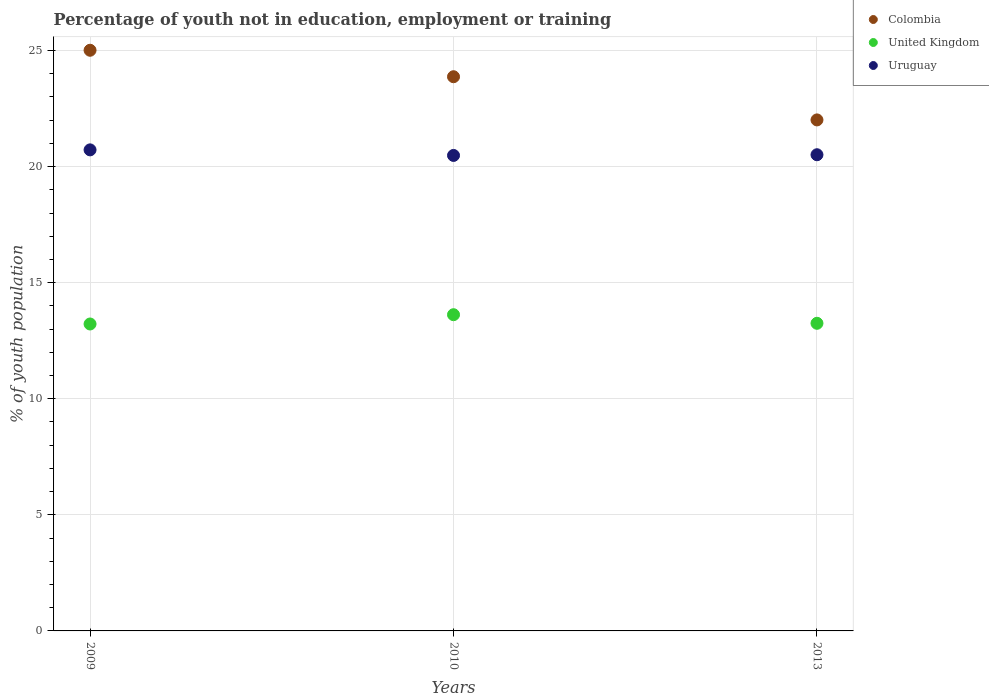What is the percentage of unemployed youth population in in Colombia in 2009?
Make the answer very short. 25.01. Across all years, what is the maximum percentage of unemployed youth population in in Colombia?
Make the answer very short. 25.01. Across all years, what is the minimum percentage of unemployed youth population in in Uruguay?
Offer a terse response. 20.48. In which year was the percentage of unemployed youth population in in Colombia maximum?
Offer a terse response. 2009. What is the total percentage of unemployed youth population in in Colombia in the graph?
Your answer should be compact. 70.89. What is the difference between the percentage of unemployed youth population in in United Kingdom in 2009 and that in 2010?
Offer a terse response. -0.4. What is the difference between the percentage of unemployed youth population in in United Kingdom in 2013 and the percentage of unemployed youth population in in Colombia in 2010?
Your answer should be very brief. -10.62. What is the average percentage of unemployed youth population in in Colombia per year?
Make the answer very short. 23.63. In the year 2010, what is the difference between the percentage of unemployed youth population in in Uruguay and percentage of unemployed youth population in in United Kingdom?
Your answer should be compact. 6.86. In how many years, is the percentage of unemployed youth population in in United Kingdom greater than 2 %?
Provide a succinct answer. 3. What is the ratio of the percentage of unemployed youth population in in Colombia in 2009 to that in 2010?
Give a very brief answer. 1.05. What is the difference between the highest and the second highest percentage of unemployed youth population in in Colombia?
Make the answer very short. 1.14. Is the sum of the percentage of unemployed youth population in in Colombia in 2010 and 2013 greater than the maximum percentage of unemployed youth population in in Uruguay across all years?
Ensure brevity in your answer.  Yes. Is it the case that in every year, the sum of the percentage of unemployed youth population in in United Kingdom and percentage of unemployed youth population in in Uruguay  is greater than the percentage of unemployed youth population in in Colombia?
Give a very brief answer. Yes. Does the percentage of unemployed youth population in in Uruguay monotonically increase over the years?
Give a very brief answer. No. Is the percentage of unemployed youth population in in Colombia strictly greater than the percentage of unemployed youth population in in Uruguay over the years?
Your answer should be compact. Yes. How many years are there in the graph?
Give a very brief answer. 3. Are the values on the major ticks of Y-axis written in scientific E-notation?
Make the answer very short. No. Does the graph contain any zero values?
Offer a terse response. No. What is the title of the graph?
Keep it short and to the point. Percentage of youth not in education, employment or training. What is the label or title of the Y-axis?
Make the answer very short. % of youth population. What is the % of youth population in Colombia in 2009?
Give a very brief answer. 25.01. What is the % of youth population of United Kingdom in 2009?
Provide a short and direct response. 13.22. What is the % of youth population of Uruguay in 2009?
Your answer should be very brief. 20.72. What is the % of youth population of Colombia in 2010?
Make the answer very short. 23.87. What is the % of youth population in United Kingdom in 2010?
Keep it short and to the point. 13.62. What is the % of youth population in Uruguay in 2010?
Your answer should be very brief. 20.48. What is the % of youth population of Colombia in 2013?
Your answer should be very brief. 22.01. What is the % of youth population of United Kingdom in 2013?
Make the answer very short. 13.25. What is the % of youth population of Uruguay in 2013?
Provide a short and direct response. 20.51. Across all years, what is the maximum % of youth population of Colombia?
Make the answer very short. 25.01. Across all years, what is the maximum % of youth population of United Kingdom?
Your answer should be very brief. 13.62. Across all years, what is the maximum % of youth population in Uruguay?
Provide a short and direct response. 20.72. Across all years, what is the minimum % of youth population of Colombia?
Your response must be concise. 22.01. Across all years, what is the minimum % of youth population of United Kingdom?
Provide a short and direct response. 13.22. Across all years, what is the minimum % of youth population in Uruguay?
Your response must be concise. 20.48. What is the total % of youth population of Colombia in the graph?
Make the answer very short. 70.89. What is the total % of youth population of United Kingdom in the graph?
Ensure brevity in your answer.  40.09. What is the total % of youth population in Uruguay in the graph?
Provide a short and direct response. 61.71. What is the difference between the % of youth population in Colombia in 2009 and that in 2010?
Provide a short and direct response. 1.14. What is the difference between the % of youth population of Uruguay in 2009 and that in 2010?
Provide a succinct answer. 0.24. What is the difference between the % of youth population of United Kingdom in 2009 and that in 2013?
Your answer should be very brief. -0.03. What is the difference between the % of youth population in Uruguay in 2009 and that in 2013?
Offer a terse response. 0.21. What is the difference between the % of youth population in Colombia in 2010 and that in 2013?
Offer a terse response. 1.86. What is the difference between the % of youth population of United Kingdom in 2010 and that in 2013?
Provide a short and direct response. 0.37. What is the difference between the % of youth population of Uruguay in 2010 and that in 2013?
Provide a succinct answer. -0.03. What is the difference between the % of youth population in Colombia in 2009 and the % of youth population in United Kingdom in 2010?
Keep it short and to the point. 11.39. What is the difference between the % of youth population of Colombia in 2009 and the % of youth population of Uruguay in 2010?
Ensure brevity in your answer.  4.53. What is the difference between the % of youth population of United Kingdom in 2009 and the % of youth population of Uruguay in 2010?
Offer a terse response. -7.26. What is the difference between the % of youth population in Colombia in 2009 and the % of youth population in United Kingdom in 2013?
Give a very brief answer. 11.76. What is the difference between the % of youth population of Colombia in 2009 and the % of youth population of Uruguay in 2013?
Make the answer very short. 4.5. What is the difference between the % of youth population in United Kingdom in 2009 and the % of youth population in Uruguay in 2013?
Give a very brief answer. -7.29. What is the difference between the % of youth population in Colombia in 2010 and the % of youth population in United Kingdom in 2013?
Your response must be concise. 10.62. What is the difference between the % of youth population in Colombia in 2010 and the % of youth population in Uruguay in 2013?
Provide a succinct answer. 3.36. What is the difference between the % of youth population of United Kingdom in 2010 and the % of youth population of Uruguay in 2013?
Your answer should be compact. -6.89. What is the average % of youth population in Colombia per year?
Make the answer very short. 23.63. What is the average % of youth population in United Kingdom per year?
Your answer should be compact. 13.36. What is the average % of youth population in Uruguay per year?
Provide a short and direct response. 20.57. In the year 2009, what is the difference between the % of youth population of Colombia and % of youth population of United Kingdom?
Make the answer very short. 11.79. In the year 2009, what is the difference between the % of youth population in Colombia and % of youth population in Uruguay?
Keep it short and to the point. 4.29. In the year 2009, what is the difference between the % of youth population of United Kingdom and % of youth population of Uruguay?
Keep it short and to the point. -7.5. In the year 2010, what is the difference between the % of youth population in Colombia and % of youth population in United Kingdom?
Your answer should be very brief. 10.25. In the year 2010, what is the difference between the % of youth population in Colombia and % of youth population in Uruguay?
Make the answer very short. 3.39. In the year 2010, what is the difference between the % of youth population of United Kingdom and % of youth population of Uruguay?
Offer a very short reply. -6.86. In the year 2013, what is the difference between the % of youth population of Colombia and % of youth population of United Kingdom?
Offer a very short reply. 8.76. In the year 2013, what is the difference between the % of youth population in Colombia and % of youth population in Uruguay?
Make the answer very short. 1.5. In the year 2013, what is the difference between the % of youth population in United Kingdom and % of youth population in Uruguay?
Your answer should be very brief. -7.26. What is the ratio of the % of youth population of Colombia in 2009 to that in 2010?
Keep it short and to the point. 1.05. What is the ratio of the % of youth population in United Kingdom in 2009 to that in 2010?
Give a very brief answer. 0.97. What is the ratio of the % of youth population in Uruguay in 2009 to that in 2010?
Provide a succinct answer. 1.01. What is the ratio of the % of youth population in Colombia in 2009 to that in 2013?
Keep it short and to the point. 1.14. What is the ratio of the % of youth population in Uruguay in 2009 to that in 2013?
Ensure brevity in your answer.  1.01. What is the ratio of the % of youth population in Colombia in 2010 to that in 2013?
Ensure brevity in your answer.  1.08. What is the ratio of the % of youth population of United Kingdom in 2010 to that in 2013?
Keep it short and to the point. 1.03. What is the ratio of the % of youth population of Uruguay in 2010 to that in 2013?
Offer a very short reply. 1. What is the difference between the highest and the second highest % of youth population of Colombia?
Offer a very short reply. 1.14. What is the difference between the highest and the second highest % of youth population of United Kingdom?
Provide a succinct answer. 0.37. What is the difference between the highest and the second highest % of youth population of Uruguay?
Provide a short and direct response. 0.21. What is the difference between the highest and the lowest % of youth population in Colombia?
Give a very brief answer. 3. What is the difference between the highest and the lowest % of youth population in United Kingdom?
Provide a short and direct response. 0.4. What is the difference between the highest and the lowest % of youth population of Uruguay?
Ensure brevity in your answer.  0.24. 